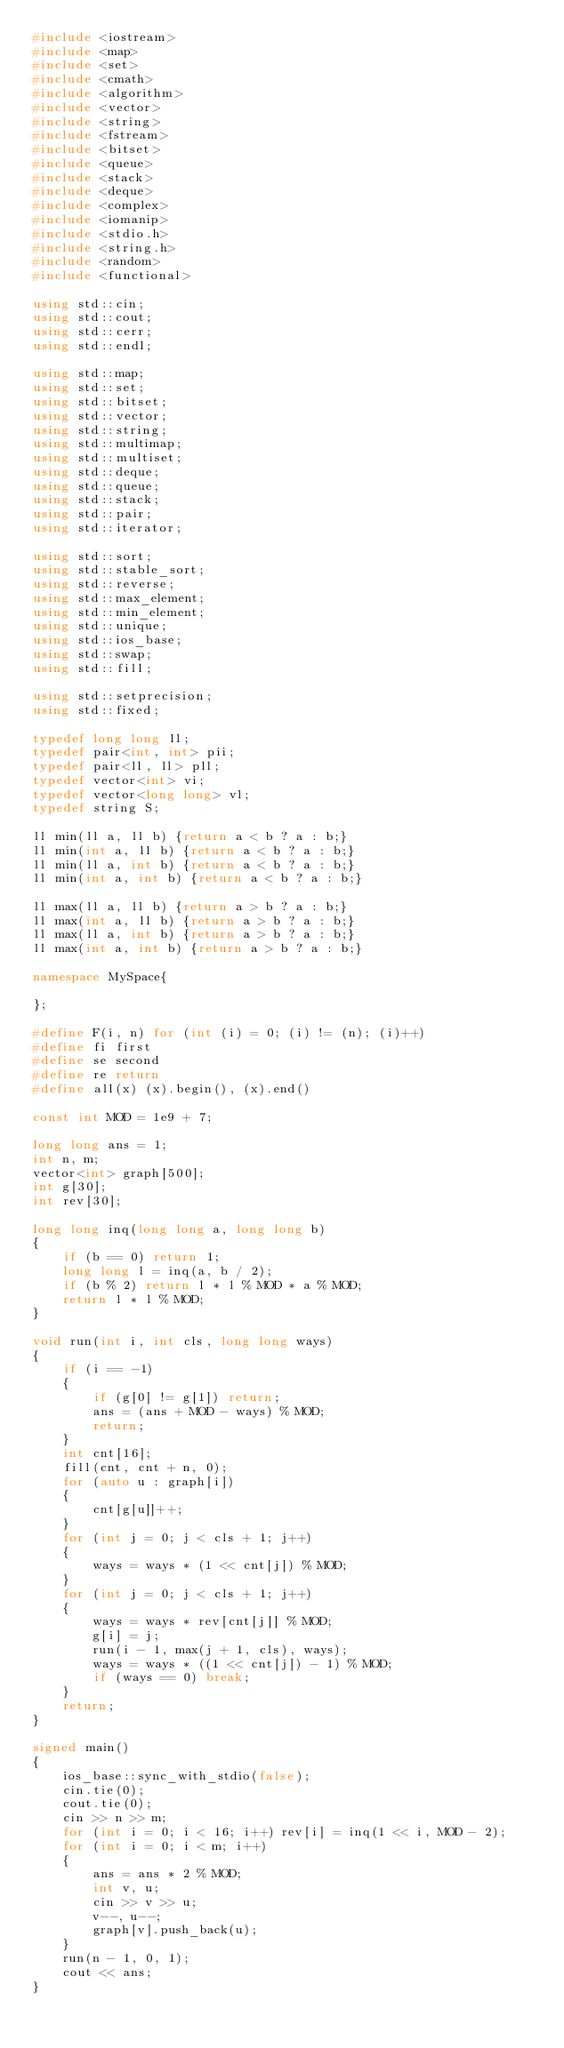Convert code to text. <code><loc_0><loc_0><loc_500><loc_500><_C++_>#include <iostream>
#include <map>
#include <set>
#include <cmath>
#include <algorithm>
#include <vector>
#include <string>
#include <fstream>
#include <bitset>
#include <queue>
#include <stack>
#include <deque>
#include <complex>
#include <iomanip>
#include <stdio.h>
#include <string.h>
#include <random>
#include <functional>

using std::cin;
using std::cout;
using std::cerr;
using std::endl;

using std::map;
using std::set;
using std::bitset;
using std::vector;
using std::string;
using std::multimap;
using std::multiset;
using std::deque;
using std::queue;
using std::stack;
using std::pair;
using std::iterator;

using std::sort;
using std::stable_sort;
using std::reverse;
using std::max_element;
using std::min_element;
using std::unique;
using std::ios_base;
using std::swap;
using std::fill;

using std::setprecision;
using std::fixed;

typedef long long ll;
typedef pair<int, int> pii;
typedef pair<ll, ll> pll;
typedef vector<int> vi;
typedef vector<long long> vl;
typedef string S;

ll min(ll a, ll b) {return a < b ? a : b;}
ll min(int a, ll b) {return a < b ? a : b;}
ll min(ll a, int b) {return a < b ? a : b;}
ll min(int a, int b) {return a < b ? a : b;}

ll max(ll a, ll b) {return a > b ? a : b;}
ll max(int a, ll b) {return a > b ? a : b;}
ll max(ll a, int b) {return a > b ? a : b;}
ll max(int a, int b) {return a > b ? a : b;}

namespace MySpace{

};

#define F(i, n) for (int (i) = 0; (i) != (n); (i)++)
#define fi first
#define se second
#define re return
#define all(x) (x).begin(), (x).end()

const int MOD = 1e9 + 7;

long long ans = 1;
int n, m;
vector<int> graph[500];
int g[30];
int rev[30];

long long inq(long long a, long long b)
{
    if (b == 0) return 1;
    long long l = inq(a, b / 2);
    if (b % 2) return l * l % MOD * a % MOD;
    return l * l % MOD;
}

void run(int i, int cls, long long ways)
{
    if (i == -1)
    {
        if (g[0] != g[1]) return;
        ans = (ans + MOD - ways) % MOD;
        return;
    }
    int cnt[16];
    fill(cnt, cnt + n, 0);
    for (auto u : graph[i])
    {
        cnt[g[u]]++;
    }
    for (int j = 0; j < cls + 1; j++)
    {
        ways = ways * (1 << cnt[j]) % MOD;
    }
    for (int j = 0; j < cls + 1; j++)
    {
        ways = ways * rev[cnt[j]] % MOD;
        g[i] = j;
        run(i - 1, max(j + 1, cls), ways);
        ways = ways * ((1 << cnt[j]) - 1) % MOD;
        if (ways == 0) break;
    }
    return;
}

signed main()
{
    ios_base::sync_with_stdio(false);
    cin.tie(0);
    cout.tie(0);
    cin >> n >> m;
    for (int i = 0; i < 16; i++) rev[i] = inq(1 << i, MOD - 2);
    for (int i = 0; i < m; i++)
    {
        ans = ans * 2 % MOD;
        int v, u;
        cin >> v >> u;
        v--, u--;
        graph[v].push_back(u);
    }
    run(n - 1, 0, 1);
    cout << ans;
}
</code> 